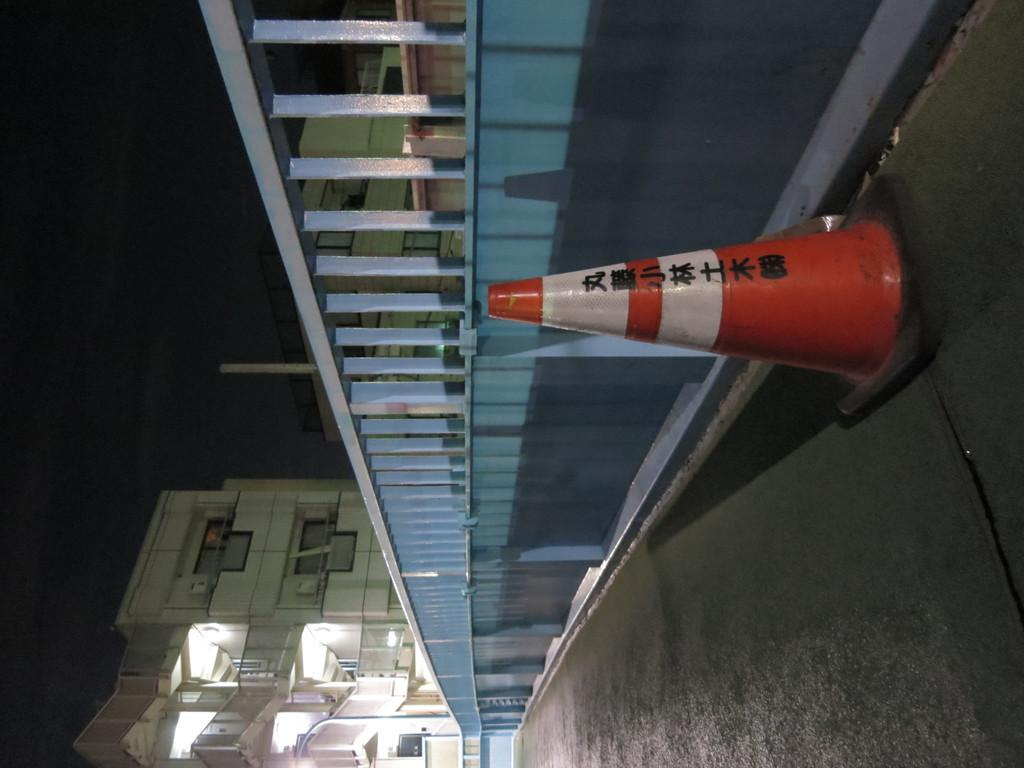What is the main feature of the image? There is a road in the image. What is located beside the road? There is a railing beside the road. What else can be seen beside the road? There is an object beside the road. What can be seen in the background of the image? There is a building in the background of the image. Where is the glove stored in the image? There is no glove present in the image. What type of birth is depicted in the image? There is no birth depicted in the image. 